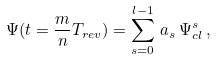<formula> <loc_0><loc_0><loc_500><loc_500>\Psi ( t = \frac { m } { n } T _ { r e v } ) = \sum _ { s = 0 } ^ { l - 1 } \, a _ { s } \, \Psi _ { c l } ^ { s } \, ,</formula> 